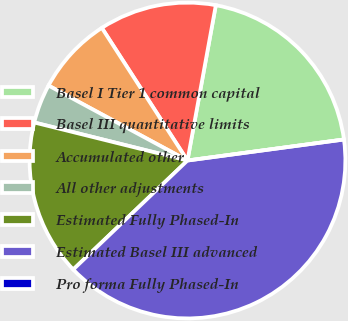<chart> <loc_0><loc_0><loc_500><loc_500><pie_chart><fcel>Basel I Tier 1 common capital<fcel>Basel III quantitative limits<fcel>Accumulated other<fcel>All other adjustments<fcel>Estimated Fully Phased-In<fcel>Estimated Basel III advanced<fcel>Pro forma Fully Phased-In<nl><fcel>20.0%<fcel>12.0%<fcel>8.0%<fcel>4.0%<fcel>16.0%<fcel>40.0%<fcel>0.0%<nl></chart> 